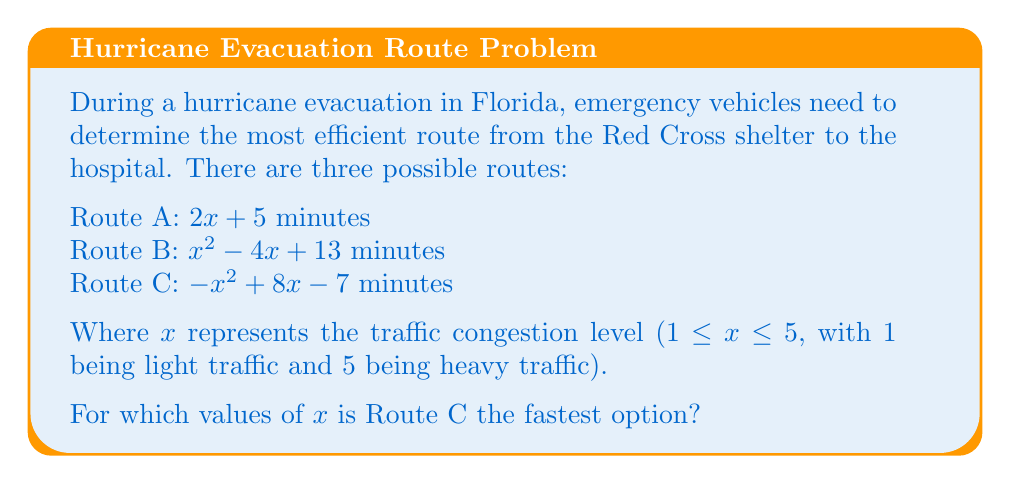Provide a solution to this math problem. To determine when Route C is the fastest, we need to compare it with Routes A and B:

1. Compare Route C with Route A:
   $-x^2 + 8x - 7 < 2x + 5$
   $-x^2 + 6x - 12 < 0$
   $(x-3)(x-4) > 0$
   $x < 3$ or $x > 4$

2. Compare Route C with Route B:
   $-x^2 + 8x - 7 < x^2 - 4x + 13$
   $-2x^2 + 12x - 20 < 0$
   $2x^2 - 12x + 20 > 0$
   $2(x^2 - 6x + 10) > 0$
   $2(x-3)^2 + 2 > 0$
   This inequality is always true for all real values of x.

3. Combine the results:
   Route C is faster than Route A when $3 < x < 4$
   Route C is always faster than Route B

4. Consider the domain constraint (1 ≤ x ≤ 5):
   The final solution is $3 < x ≤ 5$

Therefore, Route C is the fastest option when the traffic congestion level is between 3 (exclusive) and 5 (inclusive).
Answer: $3 < x \leq 5$ 